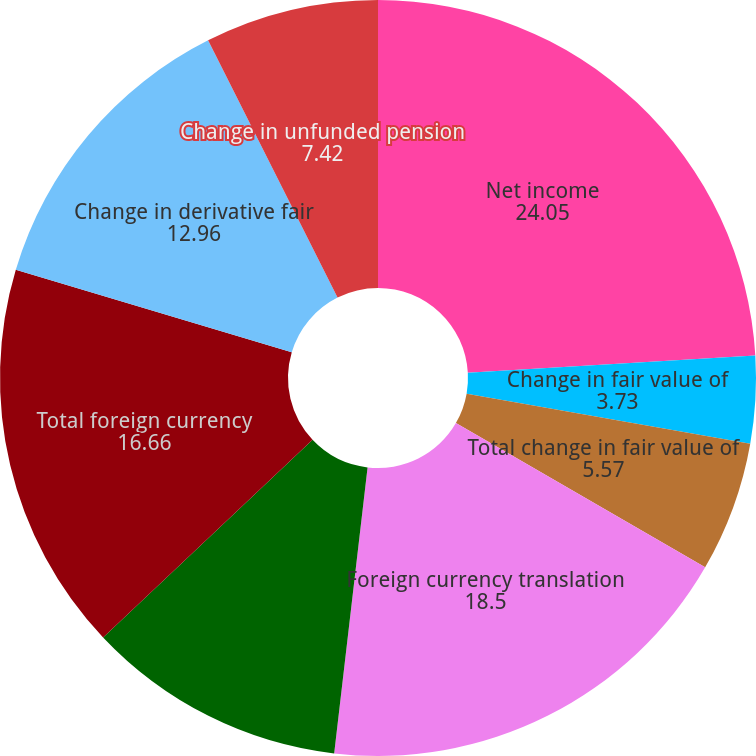<chart> <loc_0><loc_0><loc_500><loc_500><pie_chart><fcel>Net income<fcel>Change in fair value of<fcel>Total change in fair value of<fcel>Foreign currency translation<fcel>Reclassification to earnings<fcel>Total foreign currency<fcel>Change in derivative fair<fcel>Change in unfunded pension<nl><fcel>24.05%<fcel>3.73%<fcel>5.57%<fcel>18.5%<fcel>11.11%<fcel>16.66%<fcel>12.96%<fcel>7.42%<nl></chart> 